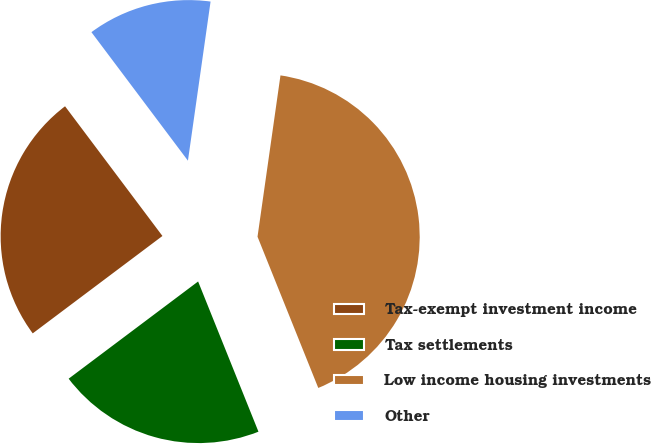Convert chart to OTSL. <chart><loc_0><loc_0><loc_500><loc_500><pie_chart><fcel>Tax-exempt investment income<fcel>Tax settlements<fcel>Low income housing investments<fcel>Other<nl><fcel>25.0%<fcel>20.83%<fcel>41.67%<fcel>12.5%<nl></chart> 